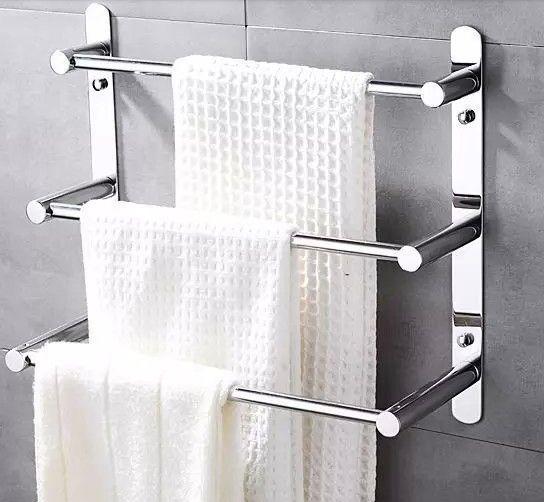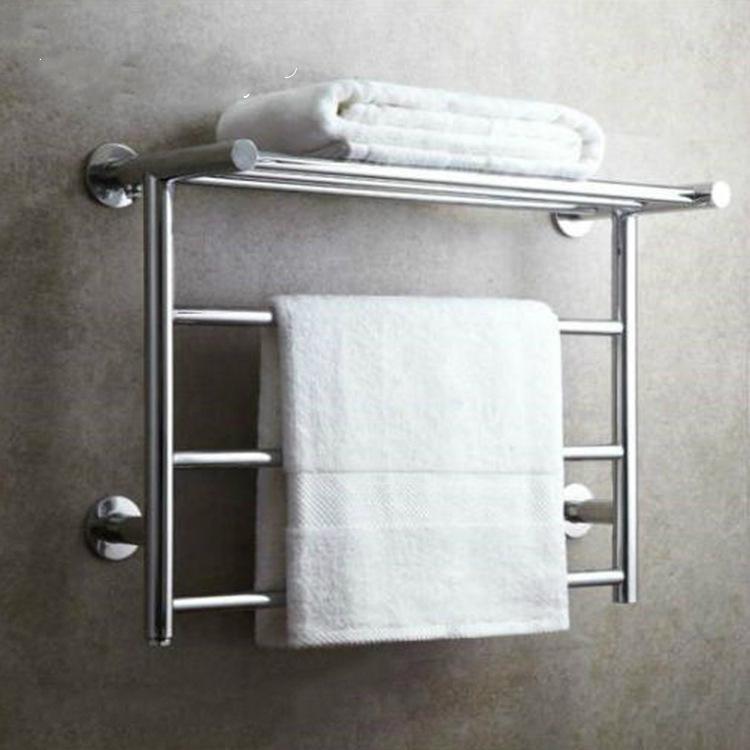The first image is the image on the left, the second image is the image on the right. For the images displayed, is the sentence "In one image, three white towels are arranged on a three-tiered chrome bathroom rack." factually correct? Answer yes or no. Yes. 